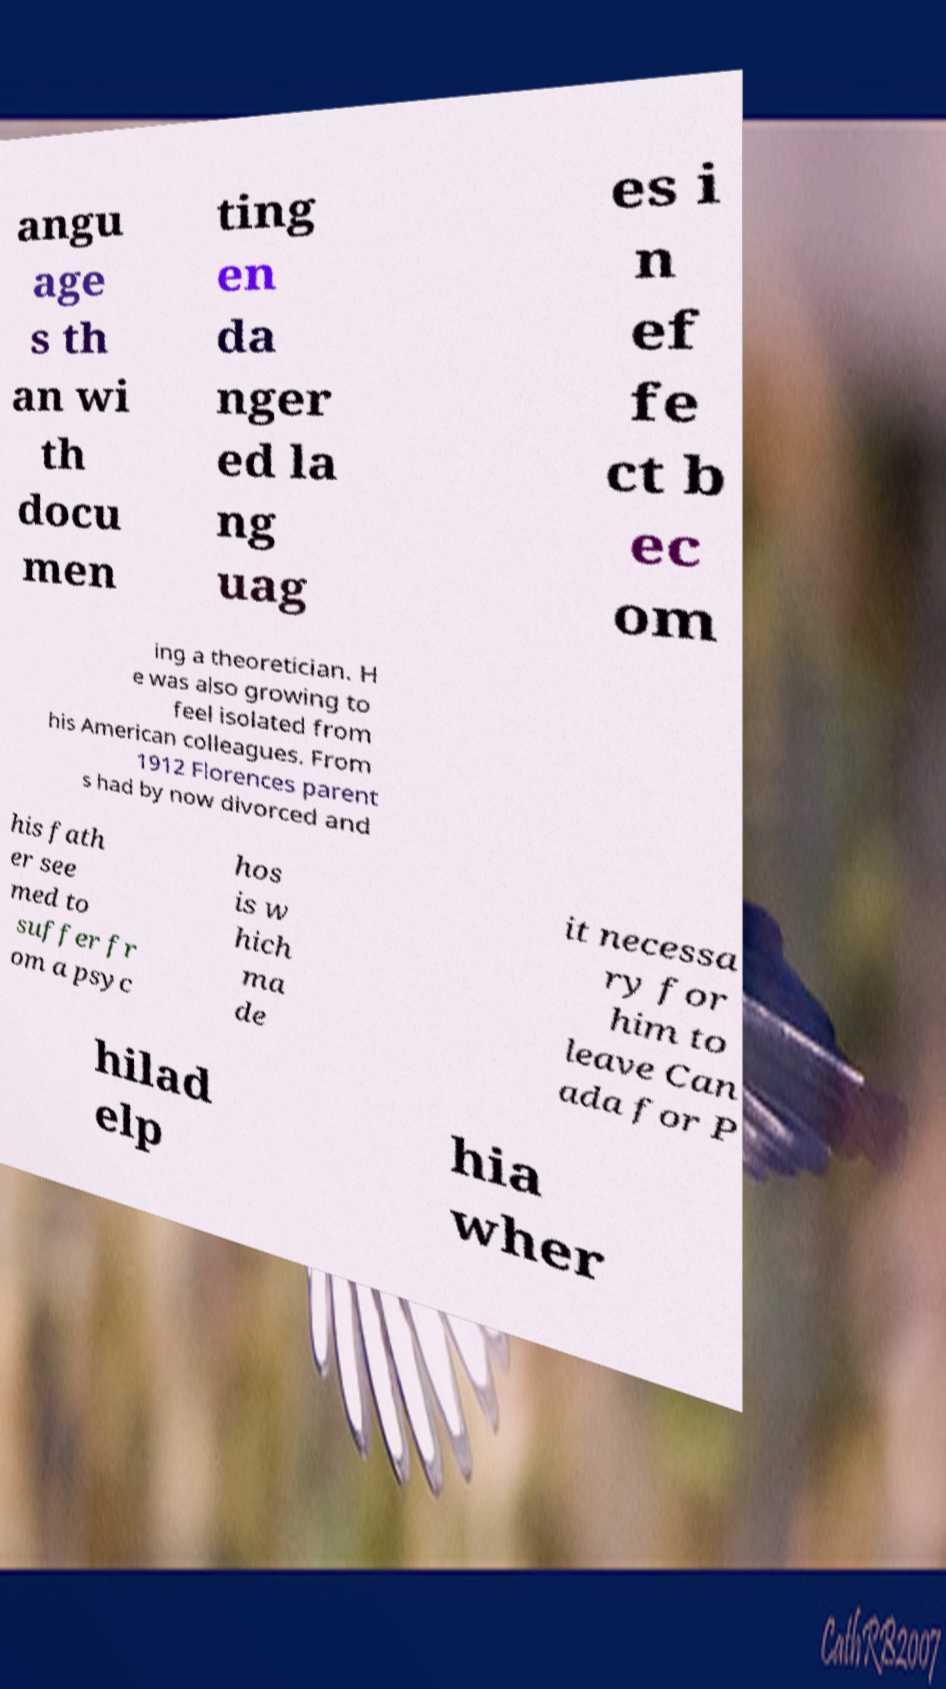Could you assist in decoding the text presented in this image and type it out clearly? angu age s th an wi th docu men ting en da nger ed la ng uag es i n ef fe ct b ec om ing a theoretician. H e was also growing to feel isolated from his American colleagues. From 1912 Florences parent s had by now divorced and his fath er see med to suffer fr om a psyc hos is w hich ma de it necessa ry for him to leave Can ada for P hilad elp hia wher 